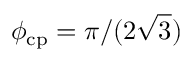<formula> <loc_0><loc_0><loc_500><loc_500>\phi _ { c p } = \pi / ( 2 \sqrt { 3 } )</formula> 